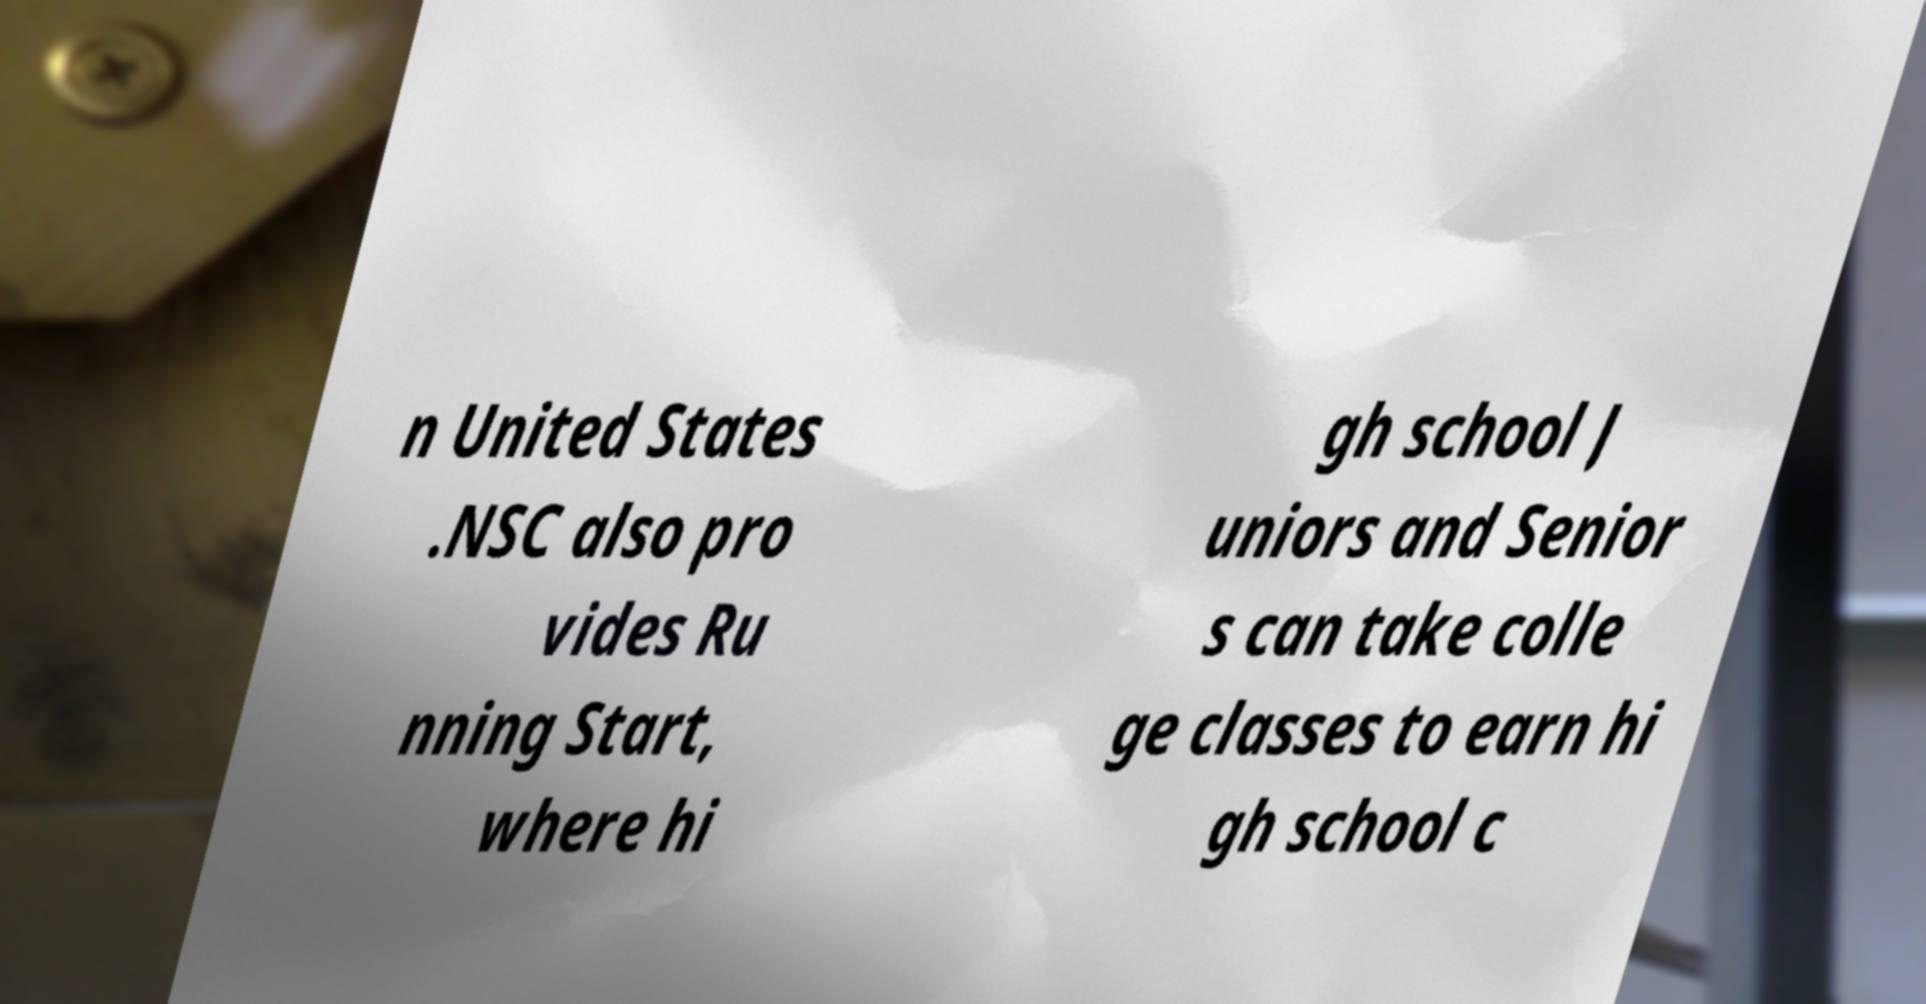There's text embedded in this image that I need extracted. Can you transcribe it verbatim? n United States .NSC also pro vides Ru nning Start, where hi gh school J uniors and Senior s can take colle ge classes to earn hi gh school c 